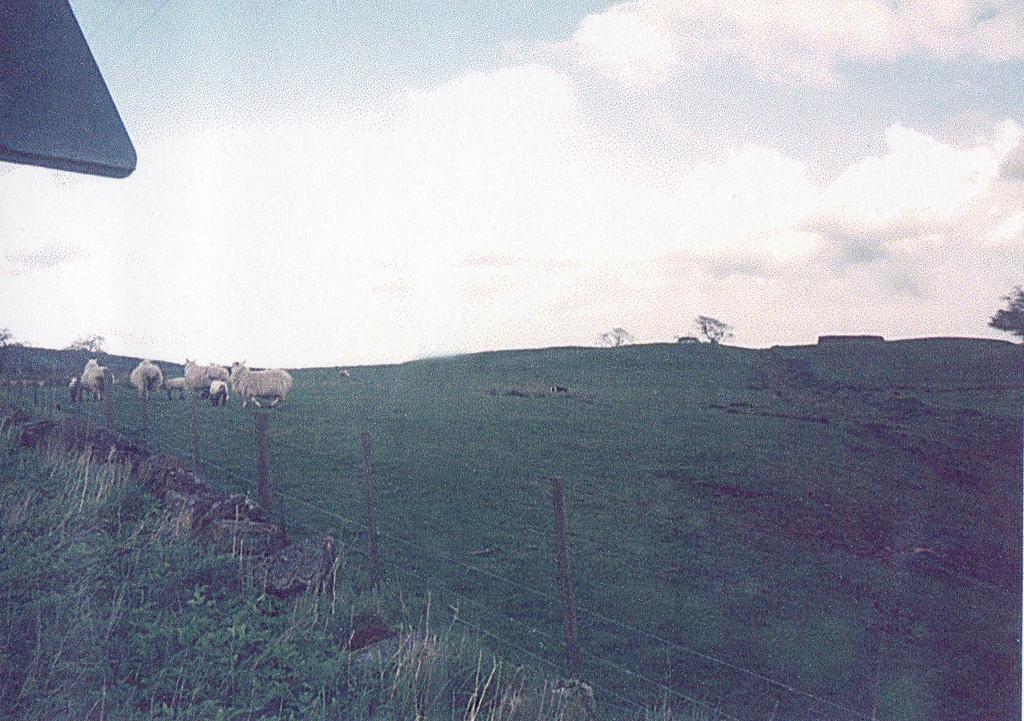How would you summarize this image in a sentence or two? In this picture we can see sheeps on the grass. On the left side of the sheep's there are poles with wire fence, grass and an object. Behind the sheep's there is the sky. 